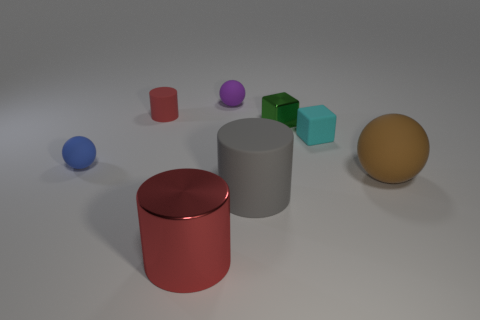Subtract all big red cylinders. How many cylinders are left? 2 Add 1 gray matte things. How many objects exist? 9 Subtract all blocks. How many objects are left? 6 Subtract all green cubes. How many red cylinders are left? 2 Subtract all brown spheres. How many spheres are left? 2 Add 7 green things. How many green things are left? 8 Add 6 small cyan metallic things. How many small cyan metallic things exist? 6 Subtract 1 purple spheres. How many objects are left? 7 Subtract 2 balls. How many balls are left? 1 Subtract all cyan balls. Subtract all red blocks. How many balls are left? 3 